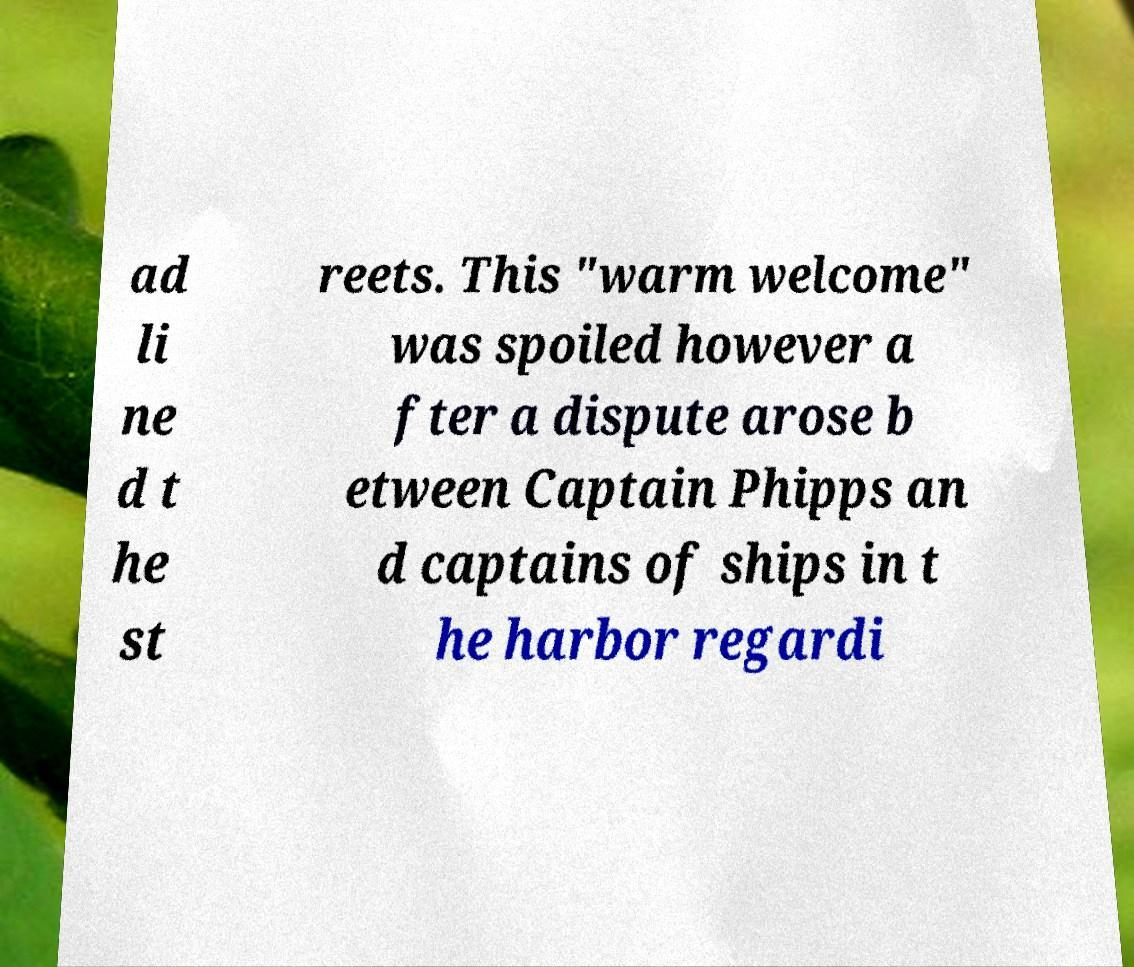Can you accurately transcribe the text from the provided image for me? ad li ne d t he st reets. This "warm welcome" was spoiled however a fter a dispute arose b etween Captain Phipps an d captains of ships in t he harbor regardi 